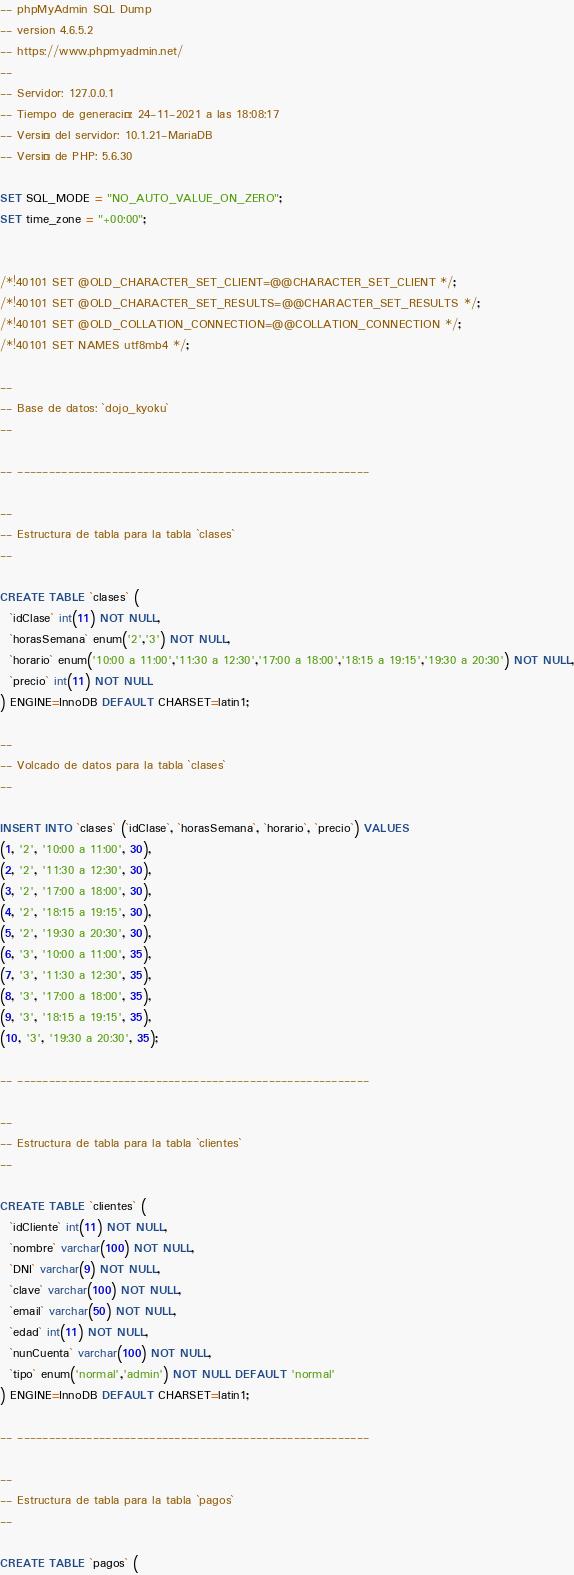<code> <loc_0><loc_0><loc_500><loc_500><_SQL_>-- phpMyAdmin SQL Dump
-- version 4.6.5.2
-- https://www.phpmyadmin.net/
--
-- Servidor: 127.0.0.1
-- Tiempo de generación: 24-11-2021 a las 18:08:17
-- Versión del servidor: 10.1.21-MariaDB
-- Versión de PHP: 5.6.30

SET SQL_MODE = "NO_AUTO_VALUE_ON_ZERO";
SET time_zone = "+00:00";


/*!40101 SET @OLD_CHARACTER_SET_CLIENT=@@CHARACTER_SET_CLIENT */;
/*!40101 SET @OLD_CHARACTER_SET_RESULTS=@@CHARACTER_SET_RESULTS */;
/*!40101 SET @OLD_COLLATION_CONNECTION=@@COLLATION_CONNECTION */;
/*!40101 SET NAMES utf8mb4 */;

--
-- Base de datos: `dojo_kyoku`
--

-- --------------------------------------------------------

--
-- Estructura de tabla para la tabla `clases`
--

CREATE TABLE `clases` (
  `idClase` int(11) NOT NULL,
  `horasSemana` enum('2','3') NOT NULL,
  `horario` enum('10:00 a 11:00','11:30 a 12:30','17:00 a 18:00','18:15 a 19:15','19:30 a 20:30') NOT NULL,
  `precio` int(11) NOT NULL
) ENGINE=InnoDB DEFAULT CHARSET=latin1;

--
-- Volcado de datos para la tabla `clases`
--

INSERT INTO `clases` (`idClase`, `horasSemana`, `horario`, `precio`) VALUES
(1, '2', '10:00 a 11:00', 30),
(2, '2', '11:30 a 12:30', 30),
(3, '2', '17:00 a 18:00', 30),
(4, '2', '18:15 a 19:15', 30),
(5, '2', '19:30 a 20:30', 30),
(6, '3', '10:00 a 11:00', 35),
(7, '3', '11:30 a 12:30', 35),
(8, '3', '17:00 a 18:00', 35),
(9, '3', '18:15 a 19:15', 35),
(10, '3', '19:30 a 20:30', 35);

-- --------------------------------------------------------

--
-- Estructura de tabla para la tabla `clientes`
--

CREATE TABLE `clientes` (
  `idCliente` int(11) NOT NULL,
  `nombre` varchar(100) NOT NULL,
  `DNI` varchar(9) NOT NULL,
  `clave` varchar(100) NOT NULL,
  `email` varchar(50) NOT NULL,
  `edad` int(11) NOT NULL,
  `nunCuenta` varchar(100) NOT NULL,
  `tipo` enum('normal','admin') NOT NULL DEFAULT 'normal'
) ENGINE=InnoDB DEFAULT CHARSET=latin1;

-- --------------------------------------------------------

--
-- Estructura de tabla para la tabla `pagos`
--

CREATE TABLE `pagos` (</code> 